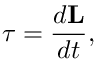<formula> <loc_0><loc_0><loc_500><loc_500>{ \tau } = { \frac { d L } { d t } } ,</formula> 